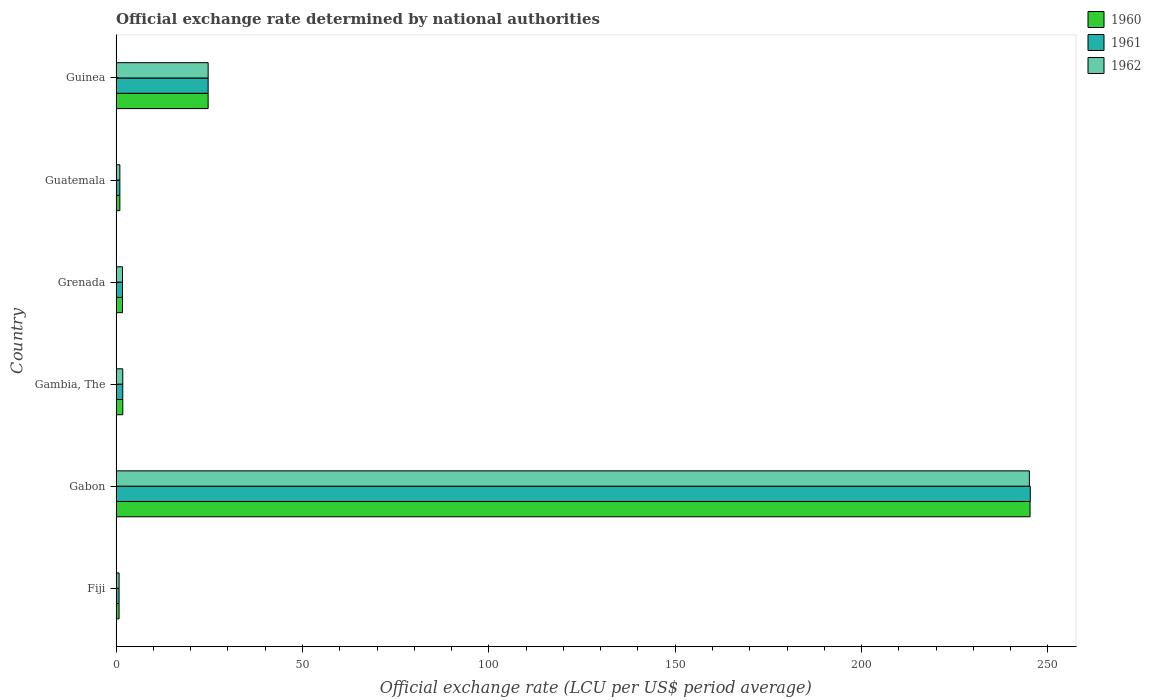How many different coloured bars are there?
Give a very brief answer. 3. How many groups of bars are there?
Your answer should be compact. 6. Are the number of bars per tick equal to the number of legend labels?
Your answer should be very brief. Yes. Are the number of bars on each tick of the Y-axis equal?
Keep it short and to the point. Yes. How many bars are there on the 4th tick from the top?
Your response must be concise. 3. What is the label of the 2nd group of bars from the top?
Your response must be concise. Guatemala. What is the official exchange rate in 1961 in Gambia, The?
Your answer should be very brief. 1.79. Across all countries, what is the maximum official exchange rate in 1961?
Provide a succinct answer. 245.26. Across all countries, what is the minimum official exchange rate in 1962?
Your answer should be compact. 0.79. In which country was the official exchange rate in 1961 maximum?
Provide a short and direct response. Gabon. In which country was the official exchange rate in 1962 minimum?
Ensure brevity in your answer.  Fiji. What is the total official exchange rate in 1961 in the graph?
Ensure brevity in your answer.  275.24. What is the difference between the official exchange rate in 1961 in Gabon and that in Grenada?
Your answer should be compact. 243.55. What is the difference between the official exchange rate in 1960 in Grenada and the official exchange rate in 1962 in Guinea?
Keep it short and to the point. -22.97. What is the average official exchange rate in 1960 per country?
Give a very brief answer. 45.86. What is the difference between the official exchange rate in 1961 and official exchange rate in 1960 in Grenada?
Give a very brief answer. 0. What is the ratio of the official exchange rate in 1960 in Guatemala to that in Guinea?
Provide a short and direct response. 0.04. Is the official exchange rate in 1960 in Fiji less than that in Grenada?
Provide a short and direct response. Yes. Is the difference between the official exchange rate in 1961 in Guatemala and Guinea greater than the difference between the official exchange rate in 1960 in Guatemala and Guinea?
Offer a very short reply. No. What is the difference between the highest and the second highest official exchange rate in 1961?
Ensure brevity in your answer.  220.58. What is the difference between the highest and the lowest official exchange rate in 1960?
Offer a terse response. 244.4. In how many countries, is the official exchange rate in 1962 greater than the average official exchange rate in 1962 taken over all countries?
Offer a terse response. 1. Is the sum of the official exchange rate in 1961 in Gabon and Gambia, The greater than the maximum official exchange rate in 1960 across all countries?
Your answer should be very brief. Yes. Is it the case that in every country, the sum of the official exchange rate in 1960 and official exchange rate in 1961 is greater than the official exchange rate in 1962?
Your response must be concise. Yes. How many legend labels are there?
Give a very brief answer. 3. How are the legend labels stacked?
Give a very brief answer. Vertical. What is the title of the graph?
Provide a short and direct response. Official exchange rate determined by national authorities. What is the label or title of the X-axis?
Provide a succinct answer. Official exchange rate (LCU per US$ period average). What is the Official exchange rate (LCU per US$ period average) of 1960 in Fiji?
Make the answer very short. 0.79. What is the Official exchange rate (LCU per US$ period average) in 1961 in Fiji?
Offer a terse response. 0.79. What is the Official exchange rate (LCU per US$ period average) of 1962 in Fiji?
Ensure brevity in your answer.  0.79. What is the Official exchange rate (LCU per US$ period average) of 1960 in Gabon?
Keep it short and to the point. 245.2. What is the Official exchange rate (LCU per US$ period average) of 1961 in Gabon?
Provide a short and direct response. 245.26. What is the Official exchange rate (LCU per US$ period average) of 1962 in Gabon?
Your answer should be very brief. 245.01. What is the Official exchange rate (LCU per US$ period average) of 1960 in Gambia, The?
Ensure brevity in your answer.  1.79. What is the Official exchange rate (LCU per US$ period average) of 1961 in Gambia, The?
Your response must be concise. 1.79. What is the Official exchange rate (LCU per US$ period average) in 1962 in Gambia, The?
Make the answer very short. 1.79. What is the Official exchange rate (LCU per US$ period average) in 1960 in Grenada?
Keep it short and to the point. 1.71. What is the Official exchange rate (LCU per US$ period average) in 1961 in Grenada?
Provide a succinct answer. 1.71. What is the Official exchange rate (LCU per US$ period average) in 1962 in Grenada?
Your response must be concise. 1.71. What is the Official exchange rate (LCU per US$ period average) in 1960 in Guinea?
Give a very brief answer. 24.69. What is the Official exchange rate (LCU per US$ period average) in 1961 in Guinea?
Ensure brevity in your answer.  24.69. What is the Official exchange rate (LCU per US$ period average) in 1962 in Guinea?
Your response must be concise. 24.69. Across all countries, what is the maximum Official exchange rate (LCU per US$ period average) in 1960?
Ensure brevity in your answer.  245.2. Across all countries, what is the maximum Official exchange rate (LCU per US$ period average) of 1961?
Make the answer very short. 245.26. Across all countries, what is the maximum Official exchange rate (LCU per US$ period average) of 1962?
Give a very brief answer. 245.01. Across all countries, what is the minimum Official exchange rate (LCU per US$ period average) of 1960?
Make the answer very short. 0.79. Across all countries, what is the minimum Official exchange rate (LCU per US$ period average) of 1961?
Your answer should be very brief. 0.79. Across all countries, what is the minimum Official exchange rate (LCU per US$ period average) in 1962?
Provide a succinct answer. 0.79. What is the total Official exchange rate (LCU per US$ period average) in 1960 in the graph?
Offer a terse response. 275.17. What is the total Official exchange rate (LCU per US$ period average) of 1961 in the graph?
Give a very brief answer. 275.24. What is the total Official exchange rate (LCU per US$ period average) of 1962 in the graph?
Provide a short and direct response. 274.99. What is the difference between the Official exchange rate (LCU per US$ period average) of 1960 in Fiji and that in Gabon?
Give a very brief answer. -244.4. What is the difference between the Official exchange rate (LCU per US$ period average) in 1961 in Fiji and that in Gabon?
Your answer should be compact. -244.47. What is the difference between the Official exchange rate (LCU per US$ period average) of 1962 in Fiji and that in Gabon?
Provide a succinct answer. -244.22. What is the difference between the Official exchange rate (LCU per US$ period average) of 1960 in Fiji and that in Gambia, The?
Give a very brief answer. -0.99. What is the difference between the Official exchange rate (LCU per US$ period average) of 1961 in Fiji and that in Gambia, The?
Offer a terse response. -0.99. What is the difference between the Official exchange rate (LCU per US$ period average) of 1962 in Fiji and that in Gambia, The?
Keep it short and to the point. -0.99. What is the difference between the Official exchange rate (LCU per US$ period average) of 1960 in Fiji and that in Grenada?
Your answer should be compact. -0.92. What is the difference between the Official exchange rate (LCU per US$ period average) in 1961 in Fiji and that in Grenada?
Offer a terse response. -0.92. What is the difference between the Official exchange rate (LCU per US$ period average) in 1962 in Fiji and that in Grenada?
Offer a terse response. -0.92. What is the difference between the Official exchange rate (LCU per US$ period average) in 1960 in Fiji and that in Guatemala?
Your answer should be compact. -0.21. What is the difference between the Official exchange rate (LCU per US$ period average) of 1961 in Fiji and that in Guatemala?
Your answer should be compact. -0.21. What is the difference between the Official exchange rate (LCU per US$ period average) in 1962 in Fiji and that in Guatemala?
Your answer should be compact. -0.21. What is the difference between the Official exchange rate (LCU per US$ period average) in 1960 in Fiji and that in Guinea?
Ensure brevity in your answer.  -23.89. What is the difference between the Official exchange rate (LCU per US$ period average) in 1961 in Fiji and that in Guinea?
Provide a succinct answer. -23.89. What is the difference between the Official exchange rate (LCU per US$ period average) of 1962 in Fiji and that in Guinea?
Keep it short and to the point. -23.89. What is the difference between the Official exchange rate (LCU per US$ period average) of 1960 in Gabon and that in Gambia, The?
Your answer should be compact. 243.41. What is the difference between the Official exchange rate (LCU per US$ period average) of 1961 in Gabon and that in Gambia, The?
Your answer should be compact. 243.47. What is the difference between the Official exchange rate (LCU per US$ period average) of 1962 in Gabon and that in Gambia, The?
Make the answer very short. 243.23. What is the difference between the Official exchange rate (LCU per US$ period average) in 1960 in Gabon and that in Grenada?
Make the answer very short. 243.48. What is the difference between the Official exchange rate (LCU per US$ period average) in 1961 in Gabon and that in Grenada?
Your answer should be very brief. 243.55. What is the difference between the Official exchange rate (LCU per US$ period average) of 1962 in Gabon and that in Grenada?
Your response must be concise. 243.3. What is the difference between the Official exchange rate (LCU per US$ period average) of 1960 in Gabon and that in Guatemala?
Ensure brevity in your answer.  244.2. What is the difference between the Official exchange rate (LCU per US$ period average) of 1961 in Gabon and that in Guatemala?
Provide a short and direct response. 244.26. What is the difference between the Official exchange rate (LCU per US$ period average) of 1962 in Gabon and that in Guatemala?
Keep it short and to the point. 244.01. What is the difference between the Official exchange rate (LCU per US$ period average) of 1960 in Gabon and that in Guinea?
Offer a terse response. 220.51. What is the difference between the Official exchange rate (LCU per US$ period average) in 1961 in Gabon and that in Guinea?
Ensure brevity in your answer.  220.58. What is the difference between the Official exchange rate (LCU per US$ period average) in 1962 in Gabon and that in Guinea?
Your response must be concise. 220.33. What is the difference between the Official exchange rate (LCU per US$ period average) of 1960 in Gambia, The and that in Grenada?
Your answer should be compact. 0.07. What is the difference between the Official exchange rate (LCU per US$ period average) in 1961 in Gambia, The and that in Grenada?
Give a very brief answer. 0.07. What is the difference between the Official exchange rate (LCU per US$ period average) of 1962 in Gambia, The and that in Grenada?
Keep it short and to the point. 0.07. What is the difference between the Official exchange rate (LCU per US$ period average) in 1960 in Gambia, The and that in Guatemala?
Make the answer very short. 0.79. What is the difference between the Official exchange rate (LCU per US$ period average) in 1961 in Gambia, The and that in Guatemala?
Give a very brief answer. 0.79. What is the difference between the Official exchange rate (LCU per US$ period average) of 1962 in Gambia, The and that in Guatemala?
Provide a short and direct response. 0.79. What is the difference between the Official exchange rate (LCU per US$ period average) of 1960 in Gambia, The and that in Guinea?
Your answer should be very brief. -22.9. What is the difference between the Official exchange rate (LCU per US$ period average) of 1961 in Gambia, The and that in Guinea?
Your answer should be very brief. -22.9. What is the difference between the Official exchange rate (LCU per US$ period average) in 1962 in Gambia, The and that in Guinea?
Offer a very short reply. -22.9. What is the difference between the Official exchange rate (LCU per US$ period average) of 1960 in Grenada and that in Guatemala?
Your answer should be very brief. 0.71. What is the difference between the Official exchange rate (LCU per US$ period average) in 1961 in Grenada and that in Guatemala?
Keep it short and to the point. 0.71. What is the difference between the Official exchange rate (LCU per US$ period average) of 1962 in Grenada and that in Guatemala?
Your answer should be compact. 0.71. What is the difference between the Official exchange rate (LCU per US$ period average) of 1960 in Grenada and that in Guinea?
Give a very brief answer. -22.97. What is the difference between the Official exchange rate (LCU per US$ period average) of 1961 in Grenada and that in Guinea?
Give a very brief answer. -22.97. What is the difference between the Official exchange rate (LCU per US$ period average) of 1962 in Grenada and that in Guinea?
Your answer should be very brief. -22.97. What is the difference between the Official exchange rate (LCU per US$ period average) in 1960 in Guatemala and that in Guinea?
Your answer should be very brief. -23.68. What is the difference between the Official exchange rate (LCU per US$ period average) of 1961 in Guatemala and that in Guinea?
Your answer should be compact. -23.68. What is the difference between the Official exchange rate (LCU per US$ period average) of 1962 in Guatemala and that in Guinea?
Provide a succinct answer. -23.68. What is the difference between the Official exchange rate (LCU per US$ period average) of 1960 in Fiji and the Official exchange rate (LCU per US$ period average) of 1961 in Gabon?
Keep it short and to the point. -244.47. What is the difference between the Official exchange rate (LCU per US$ period average) in 1960 in Fiji and the Official exchange rate (LCU per US$ period average) in 1962 in Gabon?
Provide a short and direct response. -244.22. What is the difference between the Official exchange rate (LCU per US$ period average) of 1961 in Fiji and the Official exchange rate (LCU per US$ period average) of 1962 in Gabon?
Give a very brief answer. -244.22. What is the difference between the Official exchange rate (LCU per US$ period average) of 1960 in Fiji and the Official exchange rate (LCU per US$ period average) of 1961 in Gambia, The?
Provide a short and direct response. -0.99. What is the difference between the Official exchange rate (LCU per US$ period average) in 1960 in Fiji and the Official exchange rate (LCU per US$ period average) in 1962 in Gambia, The?
Offer a very short reply. -0.99. What is the difference between the Official exchange rate (LCU per US$ period average) in 1961 in Fiji and the Official exchange rate (LCU per US$ period average) in 1962 in Gambia, The?
Provide a short and direct response. -0.99. What is the difference between the Official exchange rate (LCU per US$ period average) in 1960 in Fiji and the Official exchange rate (LCU per US$ period average) in 1961 in Grenada?
Provide a succinct answer. -0.92. What is the difference between the Official exchange rate (LCU per US$ period average) of 1960 in Fiji and the Official exchange rate (LCU per US$ period average) of 1962 in Grenada?
Your response must be concise. -0.92. What is the difference between the Official exchange rate (LCU per US$ period average) in 1961 in Fiji and the Official exchange rate (LCU per US$ period average) in 1962 in Grenada?
Provide a succinct answer. -0.92. What is the difference between the Official exchange rate (LCU per US$ period average) in 1960 in Fiji and the Official exchange rate (LCU per US$ period average) in 1961 in Guatemala?
Give a very brief answer. -0.21. What is the difference between the Official exchange rate (LCU per US$ period average) of 1960 in Fiji and the Official exchange rate (LCU per US$ period average) of 1962 in Guatemala?
Your answer should be compact. -0.21. What is the difference between the Official exchange rate (LCU per US$ period average) in 1961 in Fiji and the Official exchange rate (LCU per US$ period average) in 1962 in Guatemala?
Offer a very short reply. -0.21. What is the difference between the Official exchange rate (LCU per US$ period average) in 1960 in Fiji and the Official exchange rate (LCU per US$ period average) in 1961 in Guinea?
Offer a terse response. -23.89. What is the difference between the Official exchange rate (LCU per US$ period average) in 1960 in Fiji and the Official exchange rate (LCU per US$ period average) in 1962 in Guinea?
Give a very brief answer. -23.89. What is the difference between the Official exchange rate (LCU per US$ period average) in 1961 in Fiji and the Official exchange rate (LCU per US$ period average) in 1962 in Guinea?
Make the answer very short. -23.89. What is the difference between the Official exchange rate (LCU per US$ period average) in 1960 in Gabon and the Official exchange rate (LCU per US$ period average) in 1961 in Gambia, The?
Keep it short and to the point. 243.41. What is the difference between the Official exchange rate (LCU per US$ period average) of 1960 in Gabon and the Official exchange rate (LCU per US$ period average) of 1962 in Gambia, The?
Your answer should be very brief. 243.41. What is the difference between the Official exchange rate (LCU per US$ period average) of 1961 in Gabon and the Official exchange rate (LCU per US$ period average) of 1962 in Gambia, The?
Keep it short and to the point. 243.47. What is the difference between the Official exchange rate (LCU per US$ period average) in 1960 in Gabon and the Official exchange rate (LCU per US$ period average) in 1961 in Grenada?
Provide a succinct answer. 243.48. What is the difference between the Official exchange rate (LCU per US$ period average) of 1960 in Gabon and the Official exchange rate (LCU per US$ period average) of 1962 in Grenada?
Keep it short and to the point. 243.48. What is the difference between the Official exchange rate (LCU per US$ period average) of 1961 in Gabon and the Official exchange rate (LCU per US$ period average) of 1962 in Grenada?
Provide a succinct answer. 243.55. What is the difference between the Official exchange rate (LCU per US$ period average) of 1960 in Gabon and the Official exchange rate (LCU per US$ period average) of 1961 in Guatemala?
Provide a succinct answer. 244.2. What is the difference between the Official exchange rate (LCU per US$ period average) in 1960 in Gabon and the Official exchange rate (LCU per US$ period average) in 1962 in Guatemala?
Your response must be concise. 244.2. What is the difference between the Official exchange rate (LCU per US$ period average) of 1961 in Gabon and the Official exchange rate (LCU per US$ period average) of 1962 in Guatemala?
Your answer should be compact. 244.26. What is the difference between the Official exchange rate (LCU per US$ period average) of 1960 in Gabon and the Official exchange rate (LCU per US$ period average) of 1961 in Guinea?
Give a very brief answer. 220.51. What is the difference between the Official exchange rate (LCU per US$ period average) in 1960 in Gabon and the Official exchange rate (LCU per US$ period average) in 1962 in Guinea?
Make the answer very short. 220.51. What is the difference between the Official exchange rate (LCU per US$ period average) in 1961 in Gabon and the Official exchange rate (LCU per US$ period average) in 1962 in Guinea?
Your response must be concise. 220.58. What is the difference between the Official exchange rate (LCU per US$ period average) in 1960 in Gambia, The and the Official exchange rate (LCU per US$ period average) in 1961 in Grenada?
Offer a very short reply. 0.07. What is the difference between the Official exchange rate (LCU per US$ period average) in 1960 in Gambia, The and the Official exchange rate (LCU per US$ period average) in 1962 in Grenada?
Offer a terse response. 0.07. What is the difference between the Official exchange rate (LCU per US$ period average) in 1961 in Gambia, The and the Official exchange rate (LCU per US$ period average) in 1962 in Grenada?
Your answer should be very brief. 0.07. What is the difference between the Official exchange rate (LCU per US$ period average) in 1960 in Gambia, The and the Official exchange rate (LCU per US$ period average) in 1961 in Guatemala?
Your response must be concise. 0.79. What is the difference between the Official exchange rate (LCU per US$ period average) of 1960 in Gambia, The and the Official exchange rate (LCU per US$ period average) of 1962 in Guatemala?
Your response must be concise. 0.79. What is the difference between the Official exchange rate (LCU per US$ period average) in 1961 in Gambia, The and the Official exchange rate (LCU per US$ period average) in 1962 in Guatemala?
Keep it short and to the point. 0.79. What is the difference between the Official exchange rate (LCU per US$ period average) in 1960 in Gambia, The and the Official exchange rate (LCU per US$ period average) in 1961 in Guinea?
Provide a succinct answer. -22.9. What is the difference between the Official exchange rate (LCU per US$ period average) in 1960 in Gambia, The and the Official exchange rate (LCU per US$ period average) in 1962 in Guinea?
Provide a short and direct response. -22.9. What is the difference between the Official exchange rate (LCU per US$ period average) of 1961 in Gambia, The and the Official exchange rate (LCU per US$ period average) of 1962 in Guinea?
Offer a very short reply. -22.9. What is the difference between the Official exchange rate (LCU per US$ period average) of 1960 in Grenada and the Official exchange rate (LCU per US$ period average) of 1961 in Guatemala?
Offer a very short reply. 0.71. What is the difference between the Official exchange rate (LCU per US$ period average) of 1960 in Grenada and the Official exchange rate (LCU per US$ period average) of 1962 in Guatemala?
Keep it short and to the point. 0.71. What is the difference between the Official exchange rate (LCU per US$ period average) in 1960 in Grenada and the Official exchange rate (LCU per US$ period average) in 1961 in Guinea?
Make the answer very short. -22.97. What is the difference between the Official exchange rate (LCU per US$ period average) in 1960 in Grenada and the Official exchange rate (LCU per US$ period average) in 1962 in Guinea?
Give a very brief answer. -22.97. What is the difference between the Official exchange rate (LCU per US$ period average) of 1961 in Grenada and the Official exchange rate (LCU per US$ period average) of 1962 in Guinea?
Give a very brief answer. -22.97. What is the difference between the Official exchange rate (LCU per US$ period average) of 1960 in Guatemala and the Official exchange rate (LCU per US$ period average) of 1961 in Guinea?
Provide a succinct answer. -23.68. What is the difference between the Official exchange rate (LCU per US$ period average) of 1960 in Guatemala and the Official exchange rate (LCU per US$ period average) of 1962 in Guinea?
Your answer should be compact. -23.68. What is the difference between the Official exchange rate (LCU per US$ period average) of 1961 in Guatemala and the Official exchange rate (LCU per US$ period average) of 1962 in Guinea?
Your answer should be very brief. -23.68. What is the average Official exchange rate (LCU per US$ period average) of 1960 per country?
Keep it short and to the point. 45.86. What is the average Official exchange rate (LCU per US$ period average) of 1961 per country?
Your answer should be very brief. 45.87. What is the average Official exchange rate (LCU per US$ period average) of 1962 per country?
Your response must be concise. 45.83. What is the difference between the Official exchange rate (LCU per US$ period average) of 1960 and Official exchange rate (LCU per US$ period average) of 1962 in Fiji?
Keep it short and to the point. 0. What is the difference between the Official exchange rate (LCU per US$ period average) in 1960 and Official exchange rate (LCU per US$ period average) in 1961 in Gabon?
Provide a short and direct response. -0.07. What is the difference between the Official exchange rate (LCU per US$ period average) of 1960 and Official exchange rate (LCU per US$ period average) of 1962 in Gabon?
Provide a short and direct response. 0.18. What is the difference between the Official exchange rate (LCU per US$ period average) of 1961 and Official exchange rate (LCU per US$ period average) of 1962 in Gabon?
Give a very brief answer. 0.25. What is the difference between the Official exchange rate (LCU per US$ period average) in 1960 and Official exchange rate (LCU per US$ period average) in 1961 in Grenada?
Make the answer very short. 0. What is the difference between the Official exchange rate (LCU per US$ period average) of 1960 and Official exchange rate (LCU per US$ period average) of 1962 in Grenada?
Offer a terse response. 0. What is the difference between the Official exchange rate (LCU per US$ period average) in 1960 and Official exchange rate (LCU per US$ period average) in 1962 in Guatemala?
Give a very brief answer. 0. What is the difference between the Official exchange rate (LCU per US$ period average) in 1960 and Official exchange rate (LCU per US$ period average) in 1961 in Guinea?
Your answer should be very brief. 0. What is the ratio of the Official exchange rate (LCU per US$ period average) in 1960 in Fiji to that in Gabon?
Offer a very short reply. 0. What is the ratio of the Official exchange rate (LCU per US$ period average) of 1961 in Fiji to that in Gabon?
Give a very brief answer. 0. What is the ratio of the Official exchange rate (LCU per US$ period average) of 1962 in Fiji to that in Gabon?
Provide a succinct answer. 0. What is the ratio of the Official exchange rate (LCU per US$ period average) of 1960 in Fiji to that in Gambia, The?
Give a very brief answer. 0.44. What is the ratio of the Official exchange rate (LCU per US$ period average) in 1961 in Fiji to that in Gambia, The?
Ensure brevity in your answer.  0.44. What is the ratio of the Official exchange rate (LCU per US$ period average) in 1962 in Fiji to that in Gambia, The?
Make the answer very short. 0.44. What is the ratio of the Official exchange rate (LCU per US$ period average) of 1960 in Fiji to that in Grenada?
Make the answer very short. 0.46. What is the ratio of the Official exchange rate (LCU per US$ period average) of 1961 in Fiji to that in Grenada?
Ensure brevity in your answer.  0.46. What is the ratio of the Official exchange rate (LCU per US$ period average) in 1962 in Fiji to that in Grenada?
Your answer should be very brief. 0.46. What is the ratio of the Official exchange rate (LCU per US$ period average) in 1960 in Fiji to that in Guatemala?
Provide a short and direct response. 0.79. What is the ratio of the Official exchange rate (LCU per US$ period average) in 1961 in Fiji to that in Guatemala?
Your answer should be very brief. 0.79. What is the ratio of the Official exchange rate (LCU per US$ period average) in 1962 in Fiji to that in Guatemala?
Provide a succinct answer. 0.79. What is the ratio of the Official exchange rate (LCU per US$ period average) of 1960 in Fiji to that in Guinea?
Offer a very short reply. 0.03. What is the ratio of the Official exchange rate (LCU per US$ period average) in 1961 in Fiji to that in Guinea?
Your answer should be very brief. 0.03. What is the ratio of the Official exchange rate (LCU per US$ period average) of 1962 in Fiji to that in Guinea?
Provide a succinct answer. 0.03. What is the ratio of the Official exchange rate (LCU per US$ period average) of 1960 in Gabon to that in Gambia, The?
Ensure brevity in your answer.  137.31. What is the ratio of the Official exchange rate (LCU per US$ period average) of 1961 in Gabon to that in Gambia, The?
Ensure brevity in your answer.  137.35. What is the ratio of the Official exchange rate (LCU per US$ period average) in 1962 in Gabon to that in Gambia, The?
Provide a succinct answer. 137.21. What is the ratio of the Official exchange rate (LCU per US$ period average) in 1960 in Gabon to that in Grenada?
Your answer should be very brief. 143.03. What is the ratio of the Official exchange rate (LCU per US$ period average) of 1961 in Gabon to that in Grenada?
Give a very brief answer. 143.07. What is the ratio of the Official exchange rate (LCU per US$ period average) of 1962 in Gabon to that in Grenada?
Offer a terse response. 142.92. What is the ratio of the Official exchange rate (LCU per US$ period average) of 1960 in Gabon to that in Guatemala?
Your response must be concise. 245.2. What is the ratio of the Official exchange rate (LCU per US$ period average) in 1961 in Gabon to that in Guatemala?
Provide a short and direct response. 245.26. What is the ratio of the Official exchange rate (LCU per US$ period average) in 1962 in Gabon to that in Guatemala?
Provide a succinct answer. 245.01. What is the ratio of the Official exchange rate (LCU per US$ period average) of 1960 in Gabon to that in Guinea?
Ensure brevity in your answer.  9.93. What is the ratio of the Official exchange rate (LCU per US$ period average) in 1961 in Gabon to that in Guinea?
Ensure brevity in your answer.  9.94. What is the ratio of the Official exchange rate (LCU per US$ period average) in 1962 in Gabon to that in Guinea?
Offer a terse response. 9.93. What is the ratio of the Official exchange rate (LCU per US$ period average) in 1960 in Gambia, The to that in Grenada?
Make the answer very short. 1.04. What is the ratio of the Official exchange rate (LCU per US$ period average) in 1961 in Gambia, The to that in Grenada?
Offer a very short reply. 1.04. What is the ratio of the Official exchange rate (LCU per US$ period average) in 1962 in Gambia, The to that in Grenada?
Your answer should be very brief. 1.04. What is the ratio of the Official exchange rate (LCU per US$ period average) in 1960 in Gambia, The to that in Guatemala?
Provide a succinct answer. 1.79. What is the ratio of the Official exchange rate (LCU per US$ period average) of 1961 in Gambia, The to that in Guatemala?
Keep it short and to the point. 1.79. What is the ratio of the Official exchange rate (LCU per US$ period average) in 1962 in Gambia, The to that in Guatemala?
Your answer should be compact. 1.79. What is the ratio of the Official exchange rate (LCU per US$ period average) in 1960 in Gambia, The to that in Guinea?
Ensure brevity in your answer.  0.07. What is the ratio of the Official exchange rate (LCU per US$ period average) of 1961 in Gambia, The to that in Guinea?
Ensure brevity in your answer.  0.07. What is the ratio of the Official exchange rate (LCU per US$ period average) in 1962 in Gambia, The to that in Guinea?
Your answer should be compact. 0.07. What is the ratio of the Official exchange rate (LCU per US$ period average) of 1960 in Grenada to that in Guatemala?
Keep it short and to the point. 1.71. What is the ratio of the Official exchange rate (LCU per US$ period average) of 1961 in Grenada to that in Guatemala?
Your answer should be compact. 1.71. What is the ratio of the Official exchange rate (LCU per US$ period average) in 1962 in Grenada to that in Guatemala?
Ensure brevity in your answer.  1.71. What is the ratio of the Official exchange rate (LCU per US$ period average) in 1960 in Grenada to that in Guinea?
Offer a terse response. 0.07. What is the ratio of the Official exchange rate (LCU per US$ period average) of 1961 in Grenada to that in Guinea?
Your answer should be compact. 0.07. What is the ratio of the Official exchange rate (LCU per US$ period average) in 1962 in Grenada to that in Guinea?
Provide a short and direct response. 0.07. What is the ratio of the Official exchange rate (LCU per US$ period average) of 1960 in Guatemala to that in Guinea?
Make the answer very short. 0.04. What is the ratio of the Official exchange rate (LCU per US$ period average) in 1961 in Guatemala to that in Guinea?
Ensure brevity in your answer.  0.04. What is the ratio of the Official exchange rate (LCU per US$ period average) of 1962 in Guatemala to that in Guinea?
Your response must be concise. 0.04. What is the difference between the highest and the second highest Official exchange rate (LCU per US$ period average) of 1960?
Make the answer very short. 220.51. What is the difference between the highest and the second highest Official exchange rate (LCU per US$ period average) in 1961?
Your response must be concise. 220.58. What is the difference between the highest and the second highest Official exchange rate (LCU per US$ period average) in 1962?
Provide a short and direct response. 220.33. What is the difference between the highest and the lowest Official exchange rate (LCU per US$ period average) of 1960?
Offer a very short reply. 244.4. What is the difference between the highest and the lowest Official exchange rate (LCU per US$ period average) of 1961?
Keep it short and to the point. 244.47. What is the difference between the highest and the lowest Official exchange rate (LCU per US$ period average) of 1962?
Offer a terse response. 244.22. 